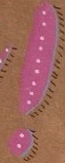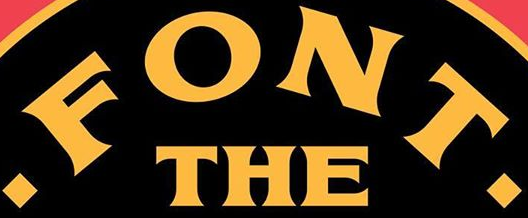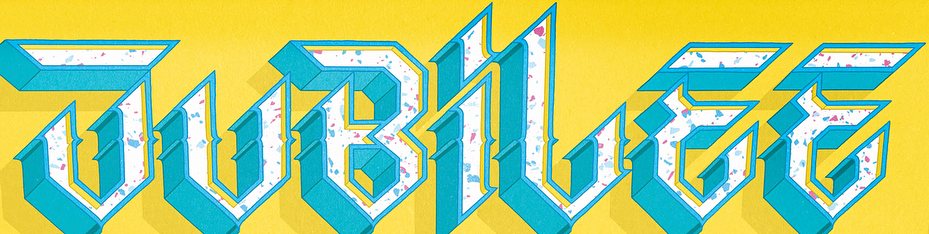Read the text from these images in sequence, separated by a semicolon. !; .FONT.; JUBiLEE 